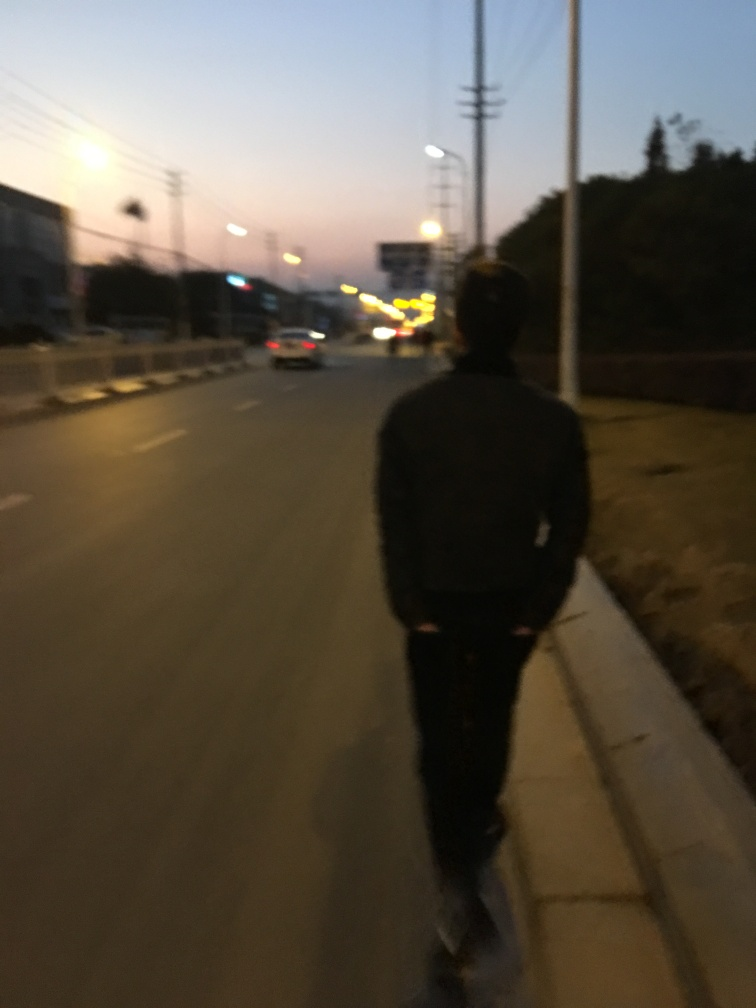Can you describe the time of day depicted in this image? The photograph appears to be taken during twilight hours, which is just after sunset. The natural light is dim, leaving the area bathed in a mix of fading daylight and the beginnings of artificial illumination from street lamps. 